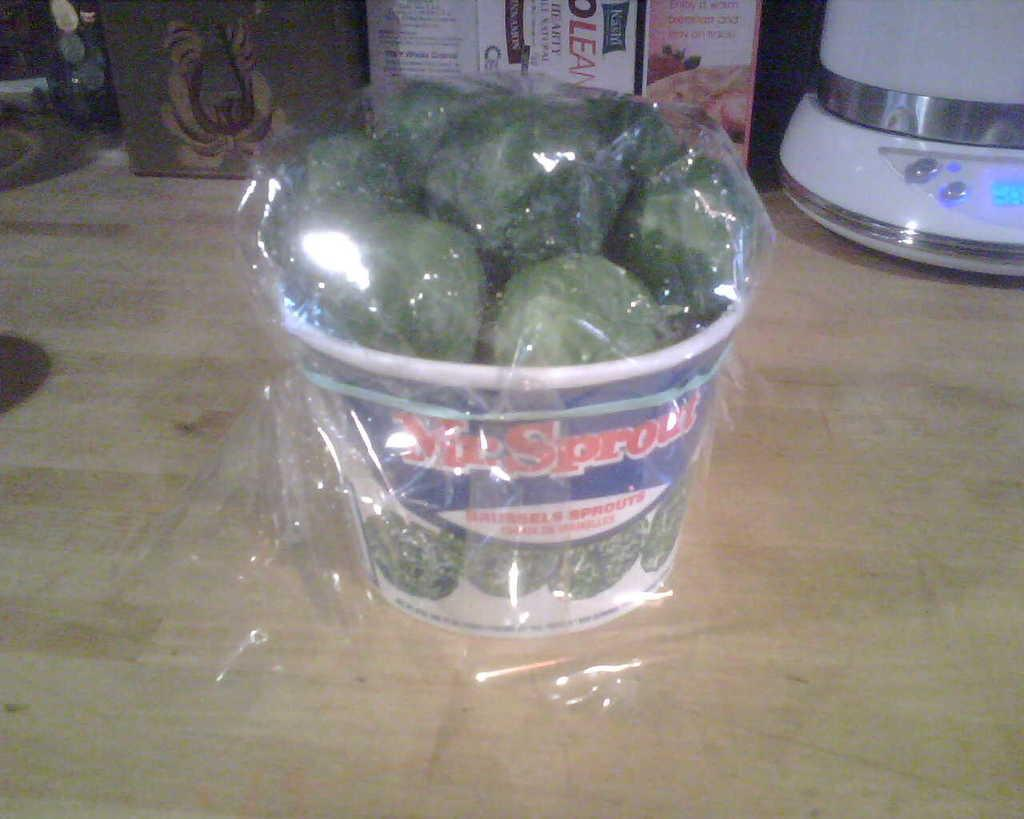<image>
Describe the image concisely. A bucket of Sprouts sitting on a kitchen counter 